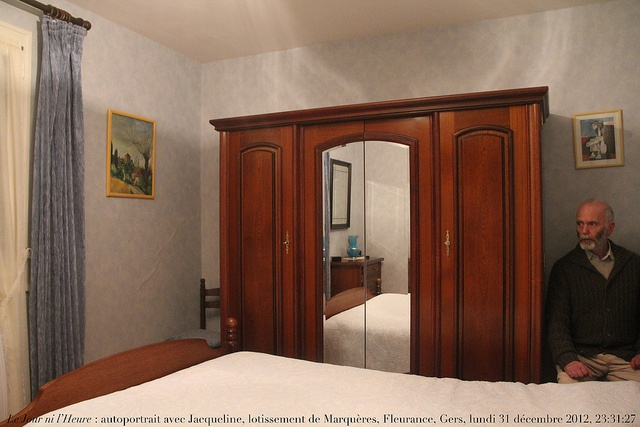Describe the objects in this image and their specific colors. I can see bed in gray, lightgray, tan, and maroon tones, people in gray, black, maroon, and brown tones, and chair in gray and black tones in this image. 